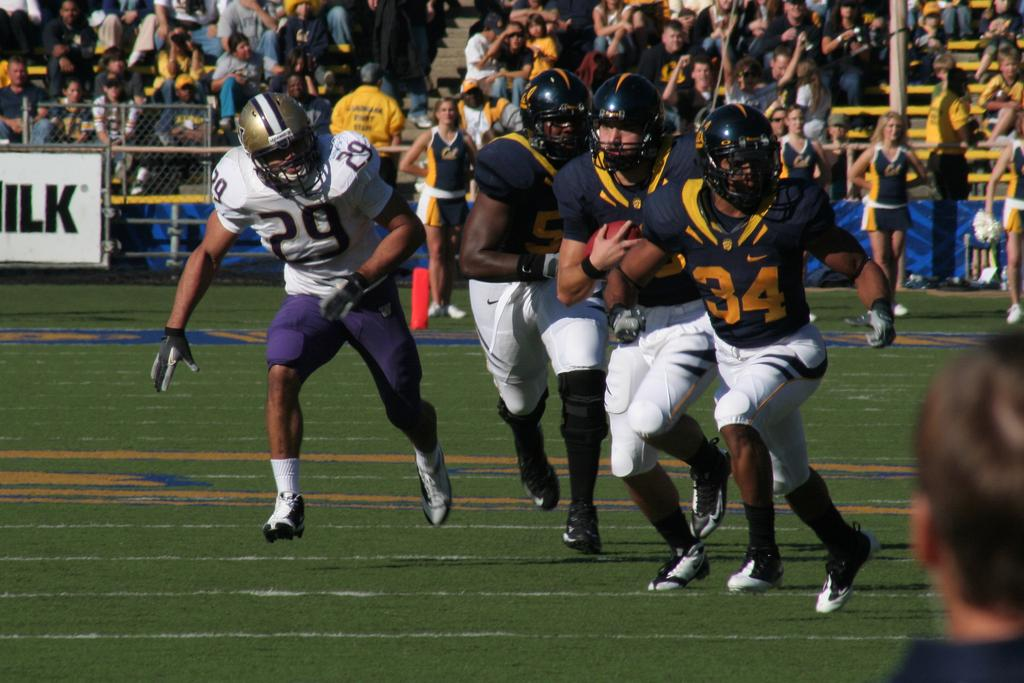What sport are the people playing in the image? The people are playing American football in the image. What protective gear are the players wearing? The people are wearing black helmets in the image. What is the surface on which the game is being played? There is green grass at the bottom of the image. What can be seen in the background of the image? There is a crowd in the background of the image. What is the ladybug's role in the American football game in the image? There is no ladybug present in the image, so it cannot have a role in the game. What is the voice of the referee in the image? The image does not provide any information about the referee's voice, as it only shows the players and the crowd. 